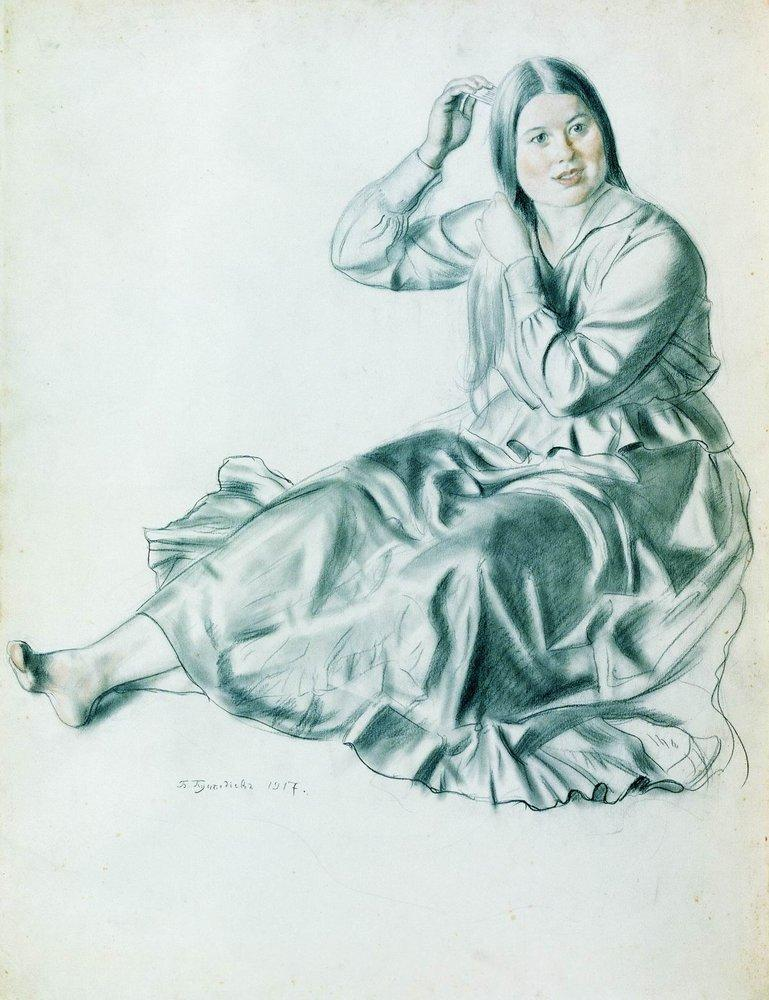What if the woman in the image could speak? What might she say? If the woman in the image could speak, she might say something poetic and reflective like, 'In the quiet of the morning, I find whispers of inspiration, threads of thoughts weaving into verses and tales. Each strand of hair I comb mirrors the unfolding stories within, a tapestry of dreams waiting to be told.' Her words would likely embody the tranquility and introspection suggested by her expression and posture. 